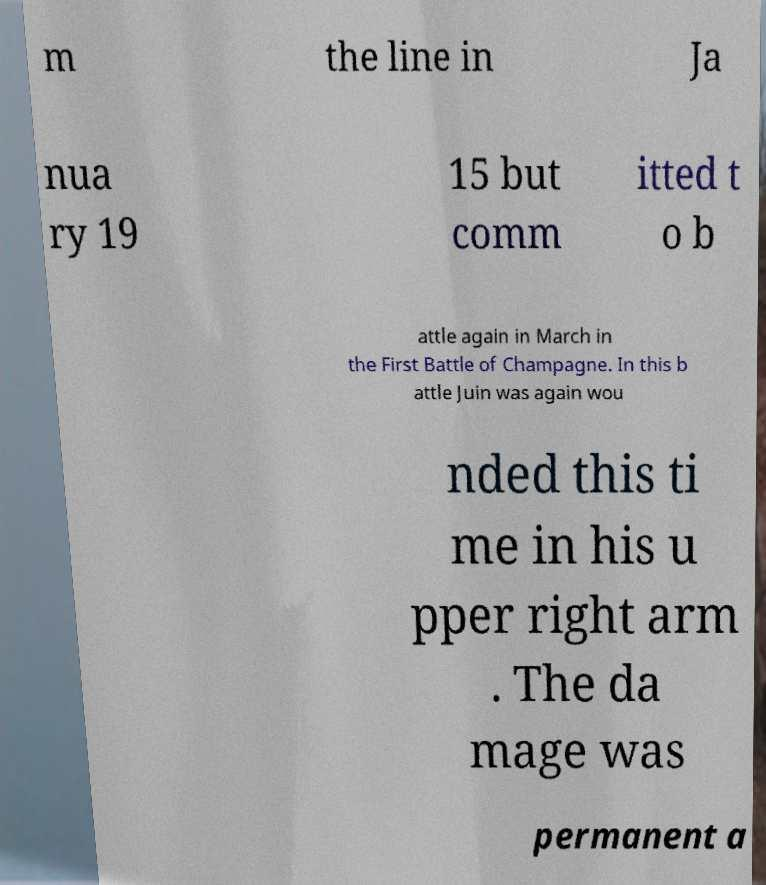Please read and relay the text visible in this image. What does it say? m the line in Ja nua ry 19 15 but comm itted t o b attle again in March in the First Battle of Champagne. In this b attle Juin was again wou nded this ti me in his u pper right arm . The da mage was permanent a 